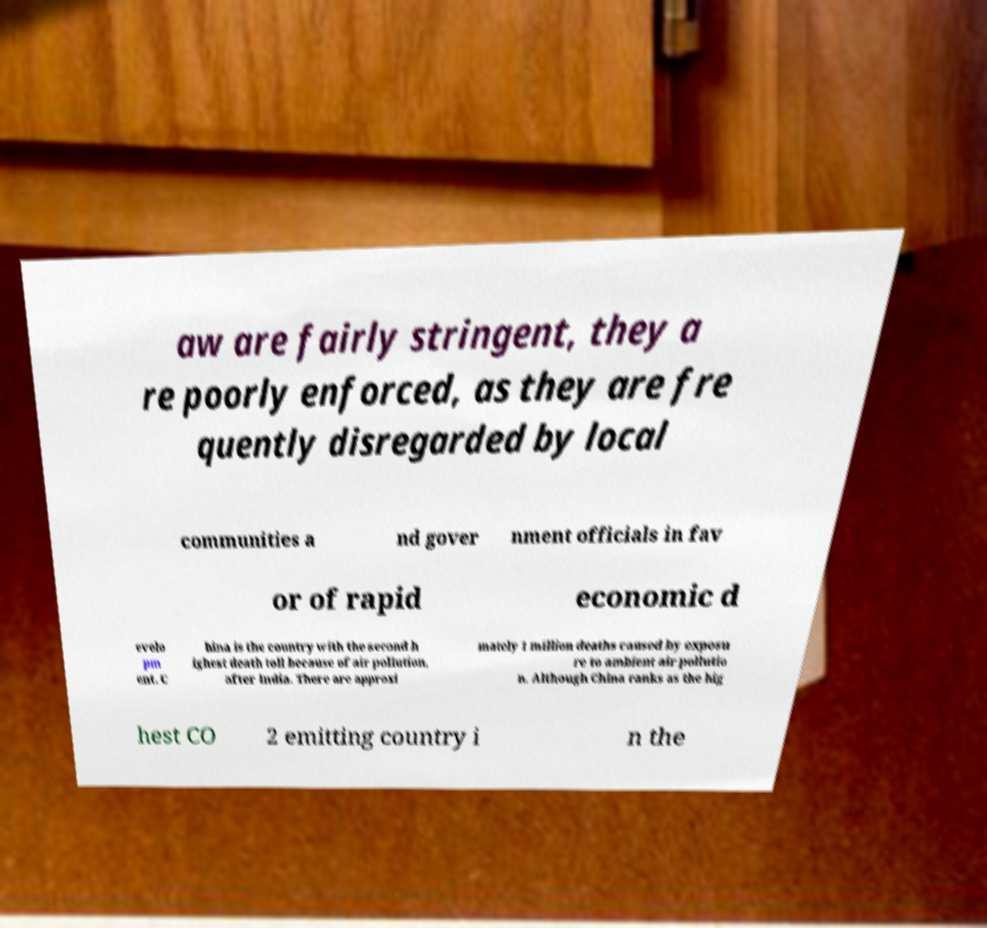For documentation purposes, I need the text within this image transcribed. Could you provide that? aw are fairly stringent, they a re poorly enforced, as they are fre quently disregarded by local communities a nd gover nment officials in fav or of rapid economic d evelo pm ent. C hina is the country with the second h ighest death toll because of air pollution, after India. There are approxi mately 1 million deaths caused by exposu re to ambient air pollutio n. Although China ranks as the hig hest CO 2 emitting country i n the 